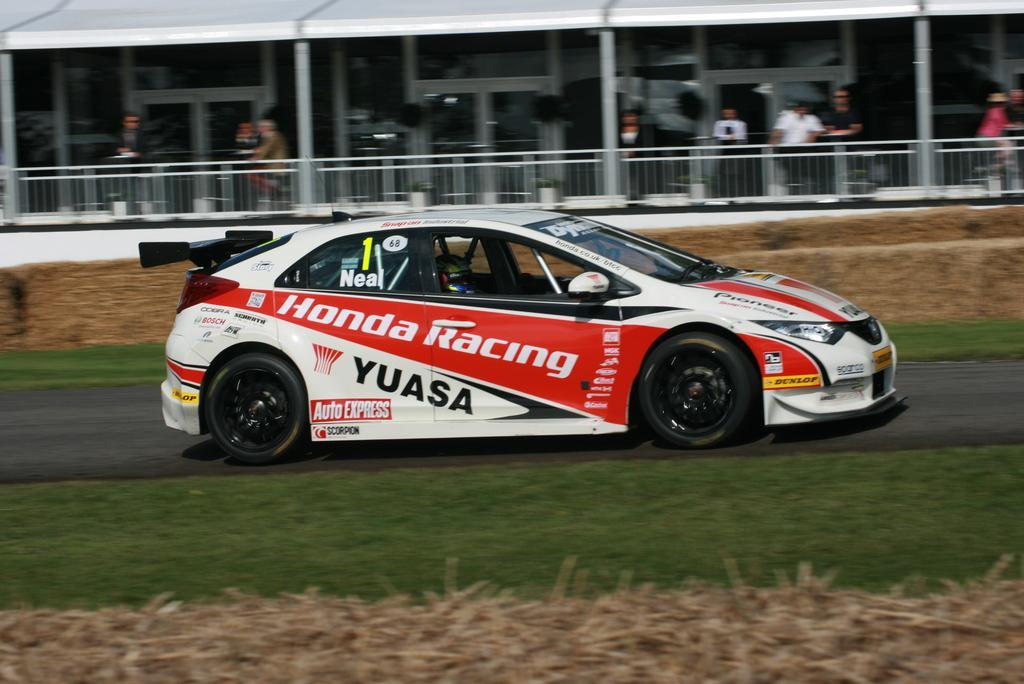How would you summarize this image in a sentence or two? In the image we can see there is a racing car which is parked on the road and beside there is a building in which people are standing. The ground is covered with grass. 